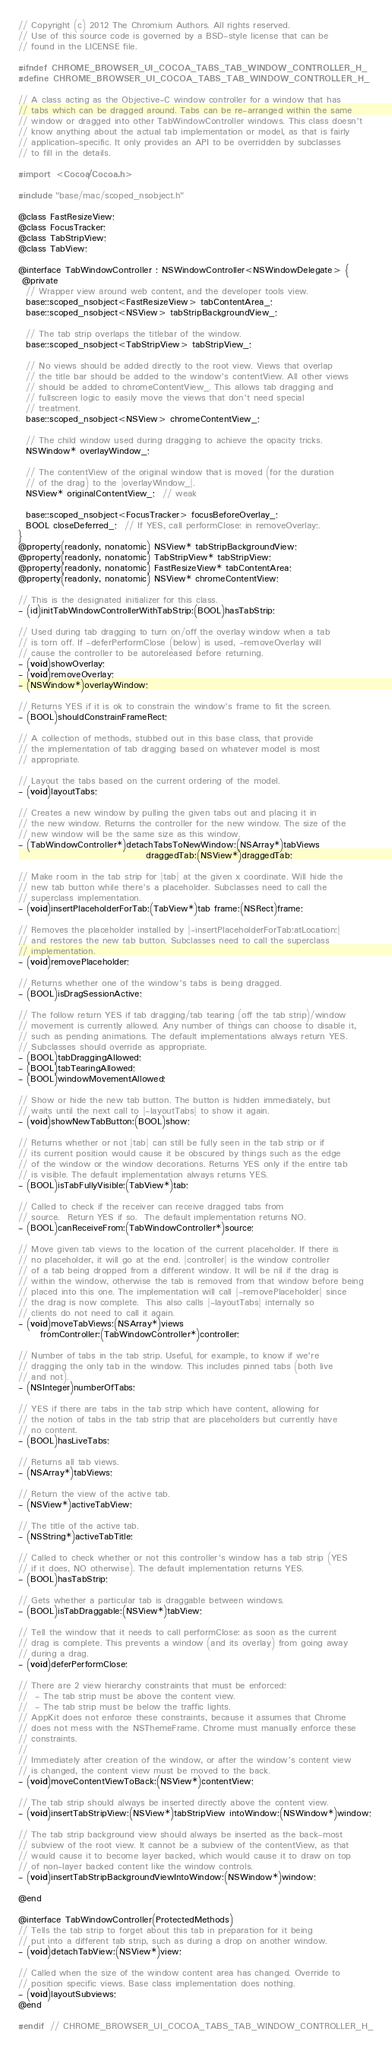<code> <loc_0><loc_0><loc_500><loc_500><_C_>// Copyright (c) 2012 The Chromium Authors. All rights reserved.
// Use of this source code is governed by a BSD-style license that can be
// found in the LICENSE file.

#ifndef CHROME_BROWSER_UI_COCOA_TABS_TAB_WINDOW_CONTROLLER_H_
#define CHROME_BROWSER_UI_COCOA_TABS_TAB_WINDOW_CONTROLLER_H_

// A class acting as the Objective-C window controller for a window that has
// tabs which can be dragged around. Tabs can be re-arranged within the same
// window or dragged into other TabWindowController windows. This class doesn't
// know anything about the actual tab implementation or model, as that is fairly
// application-specific. It only provides an API to be overridden by subclasses
// to fill in the details.

#import <Cocoa/Cocoa.h>

#include "base/mac/scoped_nsobject.h"

@class FastResizeView;
@class FocusTracker;
@class TabStripView;
@class TabView;

@interface TabWindowController : NSWindowController<NSWindowDelegate> {
 @private
  // Wrapper view around web content, and the developer tools view.
  base::scoped_nsobject<FastResizeView> tabContentArea_;
  base::scoped_nsobject<NSView> tabStripBackgroundView_;

  // The tab strip overlaps the titlebar of the window.
  base::scoped_nsobject<TabStripView> tabStripView_;

  // No views should be added directly to the root view. Views that overlap
  // the title bar should be added to the window's contentView. All other views
  // should be added to chromeContentView_. This allows tab dragging and
  // fullscreen logic to easily move the views that don't need special
  // treatment.
  base::scoped_nsobject<NSView> chromeContentView_;

  // The child window used during dragging to achieve the opacity tricks.
  NSWindow* overlayWindow_;

  // The contentView of the original window that is moved (for the duration
  // of the drag) to the |overlayWindow_|.
  NSView* originalContentView_;  // weak

  base::scoped_nsobject<FocusTracker> focusBeforeOverlay_;
  BOOL closeDeferred_;  // If YES, call performClose: in removeOverlay:.
}
@property(readonly, nonatomic) NSView* tabStripBackgroundView;
@property(readonly, nonatomic) TabStripView* tabStripView;
@property(readonly, nonatomic) FastResizeView* tabContentArea;
@property(readonly, nonatomic) NSView* chromeContentView;

// This is the designated initializer for this class.
- (id)initTabWindowControllerWithTabStrip:(BOOL)hasTabStrip;

// Used during tab dragging to turn on/off the overlay window when a tab
// is torn off. If -deferPerformClose (below) is used, -removeOverlay will
// cause the controller to be autoreleased before returning.
- (void)showOverlay;
- (void)removeOverlay;
- (NSWindow*)overlayWindow;

// Returns YES if it is ok to constrain the window's frame to fit the screen.
- (BOOL)shouldConstrainFrameRect;

// A collection of methods, stubbed out in this base class, that provide
// the implementation of tab dragging based on whatever model is most
// appropriate.

// Layout the tabs based on the current ordering of the model.
- (void)layoutTabs;

// Creates a new window by pulling the given tabs out and placing it in
// the new window. Returns the controller for the new window. The size of the
// new window will be the same size as this window.
- (TabWindowController*)detachTabsToNewWindow:(NSArray*)tabViews
                                   draggedTab:(NSView*)draggedTab;

// Make room in the tab strip for |tab| at the given x coordinate. Will hide the
// new tab button while there's a placeholder. Subclasses need to call the
// superclass implementation.
- (void)insertPlaceholderForTab:(TabView*)tab frame:(NSRect)frame;

// Removes the placeholder installed by |-insertPlaceholderForTab:atLocation:|
// and restores the new tab button. Subclasses need to call the superclass
// implementation.
- (void)removePlaceholder;

// Returns whether one of the window's tabs is being dragged.
- (BOOL)isDragSessionActive;

// The follow return YES if tab dragging/tab tearing (off the tab strip)/window
// movement is currently allowed. Any number of things can choose to disable it,
// such as pending animations. The default implementations always return YES.
// Subclasses should override as appropriate.
- (BOOL)tabDraggingAllowed;
- (BOOL)tabTearingAllowed;
- (BOOL)windowMovementAllowed;

// Show or hide the new tab button. The button is hidden immediately, but
// waits until the next call to |-layoutTabs| to show it again.
- (void)showNewTabButton:(BOOL)show;

// Returns whether or not |tab| can still be fully seen in the tab strip or if
// its current position would cause it be obscured by things such as the edge
// of the window or the window decorations. Returns YES only if the entire tab
// is visible. The default implementation always returns YES.
- (BOOL)isTabFullyVisible:(TabView*)tab;

// Called to check if the receiver can receive dragged tabs from
// source.  Return YES if so.  The default implementation returns NO.
- (BOOL)canReceiveFrom:(TabWindowController*)source;

// Move given tab views to the location of the current placeholder. If there is
// no placeholder, it will go at the end. |controller| is the window controller
// of a tab being dropped from a different window. It will be nil if the drag is
// within the window, otherwise the tab is removed from that window before being
// placed into this one. The implementation will call |-removePlaceholder| since
// the drag is now complete.  This also calls |-layoutTabs| internally so
// clients do not need to call it again.
- (void)moveTabViews:(NSArray*)views
      fromController:(TabWindowController*)controller;

// Number of tabs in the tab strip. Useful, for example, to know if we're
// dragging the only tab in the window. This includes pinned tabs (both live
// and not).
- (NSInteger)numberOfTabs;

// YES if there are tabs in the tab strip which have content, allowing for
// the notion of tabs in the tab strip that are placeholders but currently have
// no content.
- (BOOL)hasLiveTabs;

// Returns all tab views.
- (NSArray*)tabViews;

// Return the view of the active tab.
- (NSView*)activeTabView;

// The title of the active tab.
- (NSString*)activeTabTitle;

// Called to check whether or not this controller's window has a tab strip (YES
// if it does, NO otherwise). The default implementation returns YES.
- (BOOL)hasTabStrip;

// Gets whether a particular tab is draggable between windows.
- (BOOL)isTabDraggable:(NSView*)tabView;

// Tell the window that it needs to call performClose: as soon as the current
// drag is complete. This prevents a window (and its overlay) from going away
// during a drag.
- (void)deferPerformClose;

// There are 2 view hierarchy constraints that must be enforced:
//  - The tab strip must be above the content view.
//  - The tab strip must be below the traffic lights.
// AppKit does not enforce these constraints, because it assumes that Chrome
// does not mess with the NSThemeFrame. Chrome must manually enforce these
// constraints.
//
// Immediately after creation of the window, or after the window's content view
// is changed, the content view must be moved to the back.
- (void)moveContentViewToBack:(NSView*)contentView;

// The tab strip should always be inserted directly above the content view.
- (void)insertTabStripView:(NSView*)tabStripView intoWindow:(NSWindow*)window;

// The tab strip background view should always be inserted as the back-most
// subview of the root view. It cannot be a subview of the contentView, as that
// would cause it to become layer backed, which would cause it to draw on top
// of non-layer backed content like the window controls.
- (void)insertTabStripBackgroundViewIntoWindow:(NSWindow*)window;

@end

@interface TabWindowController(ProtectedMethods)
// Tells the tab strip to forget about this tab in preparation for it being
// put into a different tab strip, such as during a drop on another window.
- (void)detachTabView:(NSView*)view;

// Called when the size of the window content area has changed. Override to
// position specific views. Base class implementation does nothing.
- (void)layoutSubviews;
@end

#endif  // CHROME_BROWSER_UI_COCOA_TABS_TAB_WINDOW_CONTROLLER_H_
</code> 